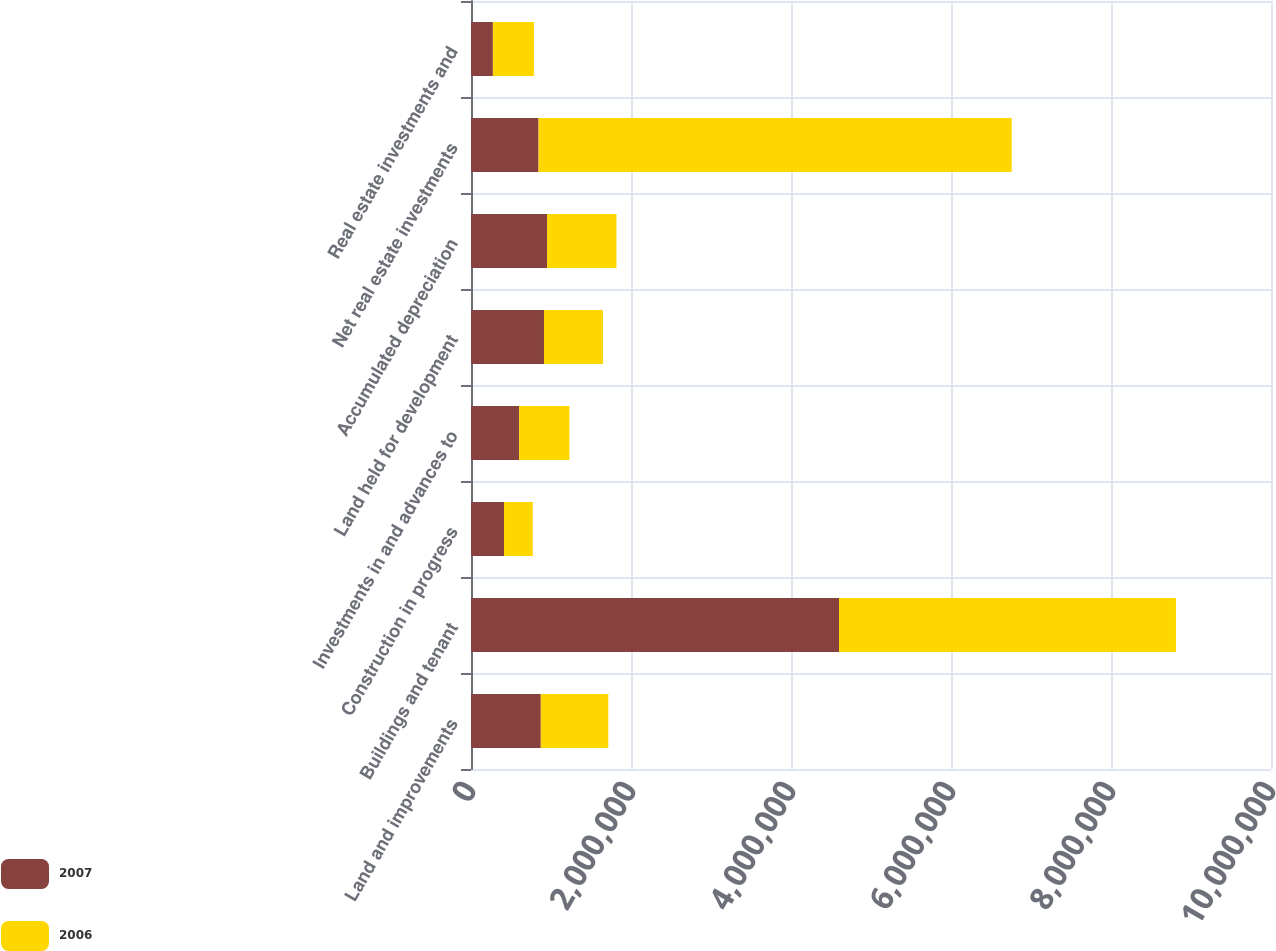<chart> <loc_0><loc_0><loc_500><loc_500><stacked_bar_chart><ecel><fcel>Land and improvements<fcel>Buildings and tenant<fcel>Construction in progress<fcel>Investments in and advances to<fcel>Land held for development<fcel>Accumulated depreciation<fcel>Net real estate investments<fcel>Real estate investments and<nl><fcel>2007<fcel>872372<fcel>4.60041e+06<fcel>412729<fcel>601801<fcel>912448<fcel>951375<fcel>844091<fcel>273591<nl><fcel>2006<fcel>844091<fcel>4.2116e+06<fcel>359765<fcel>628323<fcel>737752<fcel>867079<fcel>5.91445e+06<fcel>512925<nl></chart> 